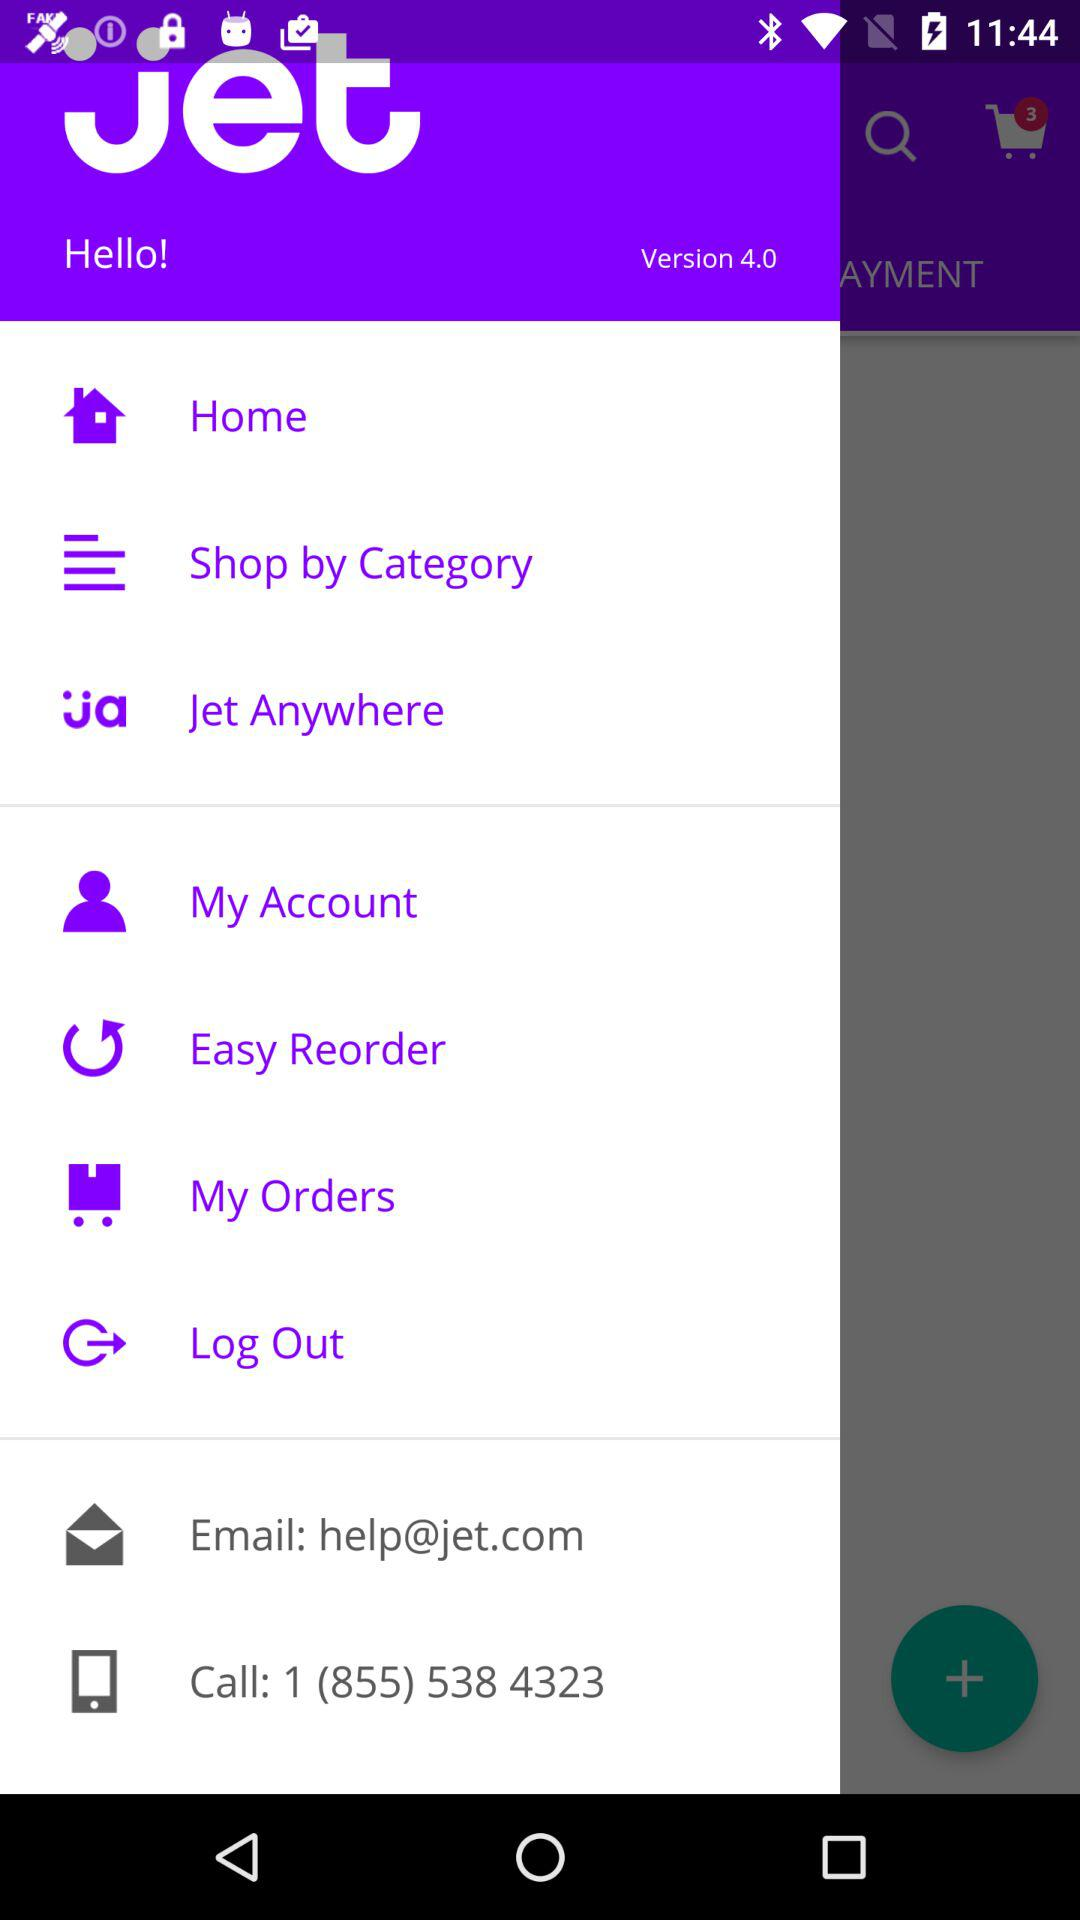What is the email address? The email address is help@jet.com. 